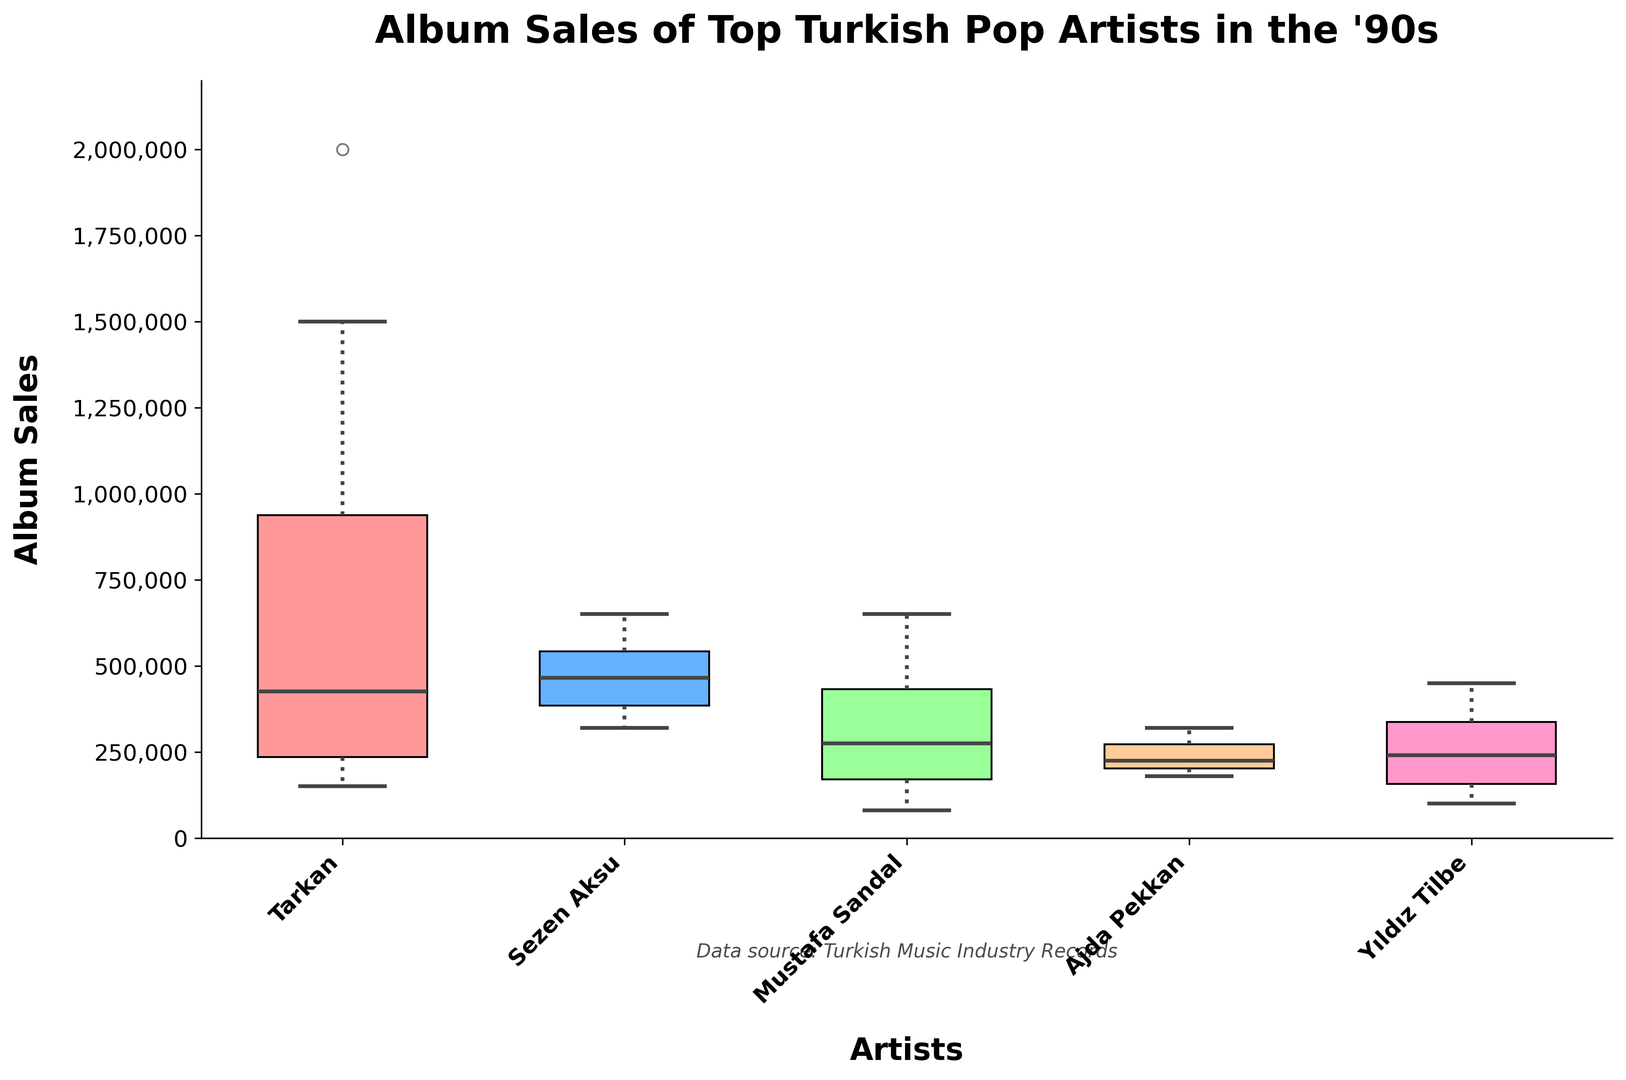Which artist has the highest median album sales? The median is the middle value when the sales numbers are ordered. The figure shows that Tarkan has the highest median box level, indicating the highest median album sales.
Answer: Tarkan What is the range of album sales for Ajda Pekkan? The range is the difference between the maximum and minimum values. The top whisker reaches around 320,000, and the bottom whisker reaches around 180,000. Therefore, the range is 320,000 - 180,000 = 140,000.
Answer: 140,000 Which artist has the widest interquartile range (IQR) for album sales? The IQR is represented by the height of the box. Tarkan’s box is the widest because it stretches from approximately 180,000 to 1,000,000. This means Tarkan has the widest IQR.
Answer: Tarkan Who has the most consistent album sales across the years? Consistency in a box plot is indicated by a smaller box and whiskers. Sezen Aksu has the shortest box and whiskers, suggesting her album sales are the most consistent.
Answer: Sezen Aksu How does Yıldız Tilbe's highest album sales in a year compare to Mustafa Sandal's highest album sales? According to the box plot, Yıldız Tilbe's highest sales reach up to 450,000, whereas Mustafa Sandal's highest sales peak at 650,000, making Mustafa Sandal's higher.
Answer: Mustafa Sandal What is the combined median album sales for Tarkan and Sezen Aksu? The median sales for Tarkan are about 1,000,000 and for Sezen Aksu are around 500,000. Combined, their median sales are 1,000,000 + 500,000 = 1,500,000.
Answer: 1,500,000 Which artist shows the greatest increase in album sales over the decade? By checking the upper whisker endpoints, Tarkan's sales rise from around 150,000 in 1990 to 2,000,000 in 1999, showing the greatest increase.
Answer: Tarkan What is the median album sales difference between Ajda Pekkan and Yıldız Tilbe? Ajda Pekkan’s median sales are around 230,000, while Yıldız Tilbe’s are around 300,000. The difference is 300,000 - 230,000 = 70,000.
Answer: 70,000 Among all artists, who has the smallest difference between the first and third quartile album sales? The first and third quartiles form the box edges; Sezen Aksu has the smallest box height, meaning her Q3-Q1 difference is the smallest.
Answer: Sezen Aksu 